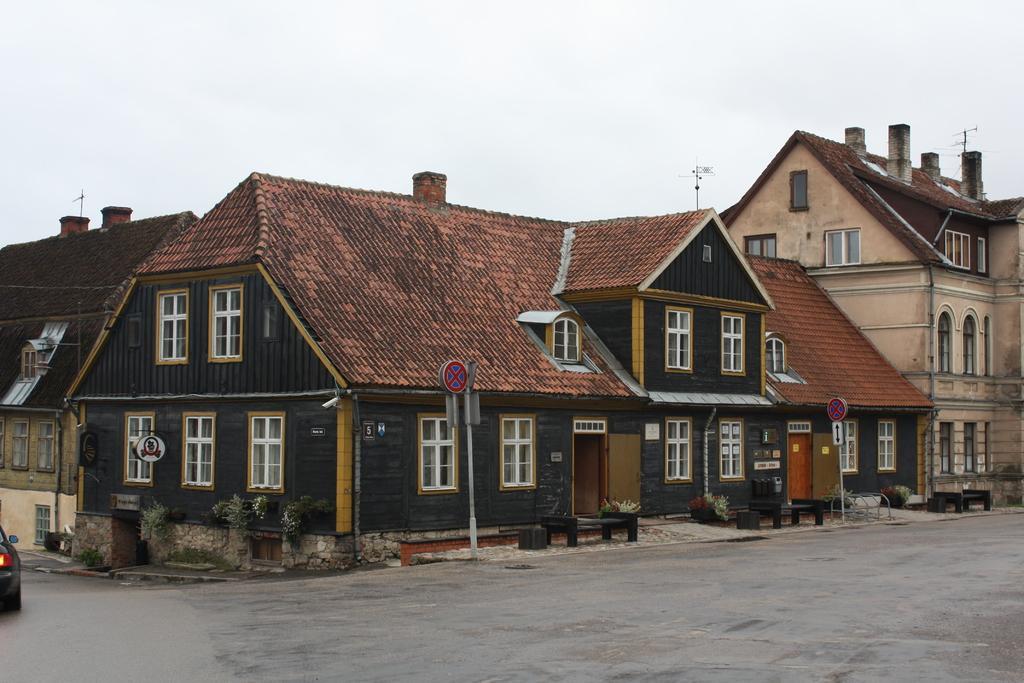In one or two sentences, can you explain what this image depicts? In this image, we can see a few houses. We can see the ground with some objects. We can see a partially covered vehicle on the left. We can see some poles and sign boards. There are a few plants. We can also see some grass and the sky. 